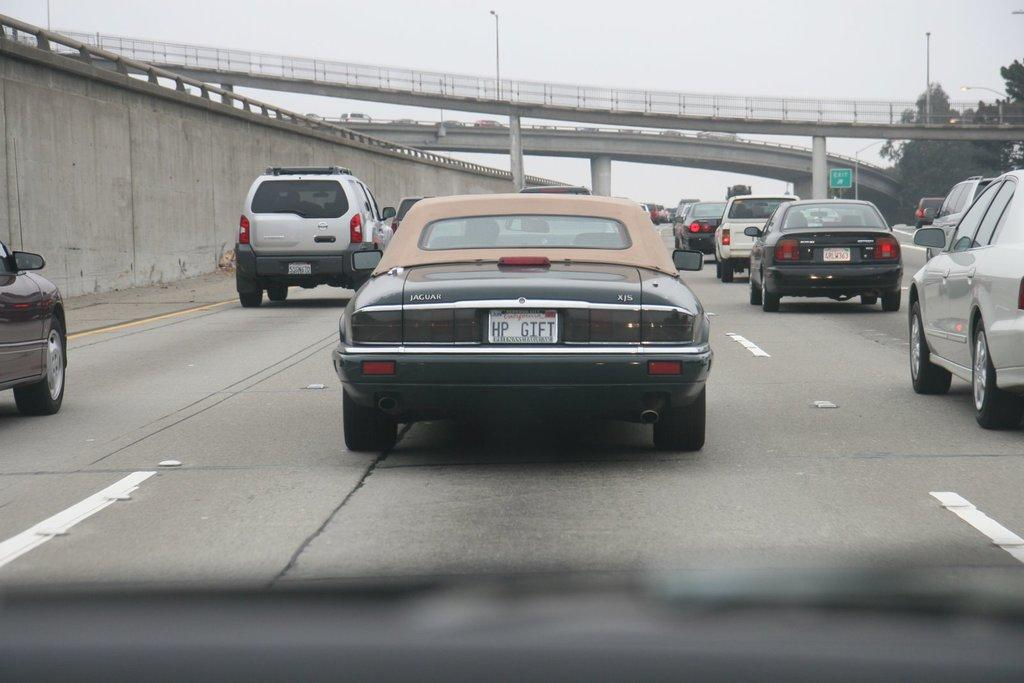What can be seen on the road in the image? There are vehicles on the road in the image. Where are the vehicles located in relation to the bridge? The vehicles are beside a bridge in the image. What type of structure is present in the image? There is a bridge in the image. What is visible at the top of the image? The sky is visible at the top of the image. What type of vegetation is in the top right of the image? There are trees in the top right of the image. What type of fuel is being used by the vehicles in the image? The type of fuel being used by the vehicles cannot be determined from the image. What is the sun's position in the image? The sun is not visible in the image; only the sky is visible at the top. 